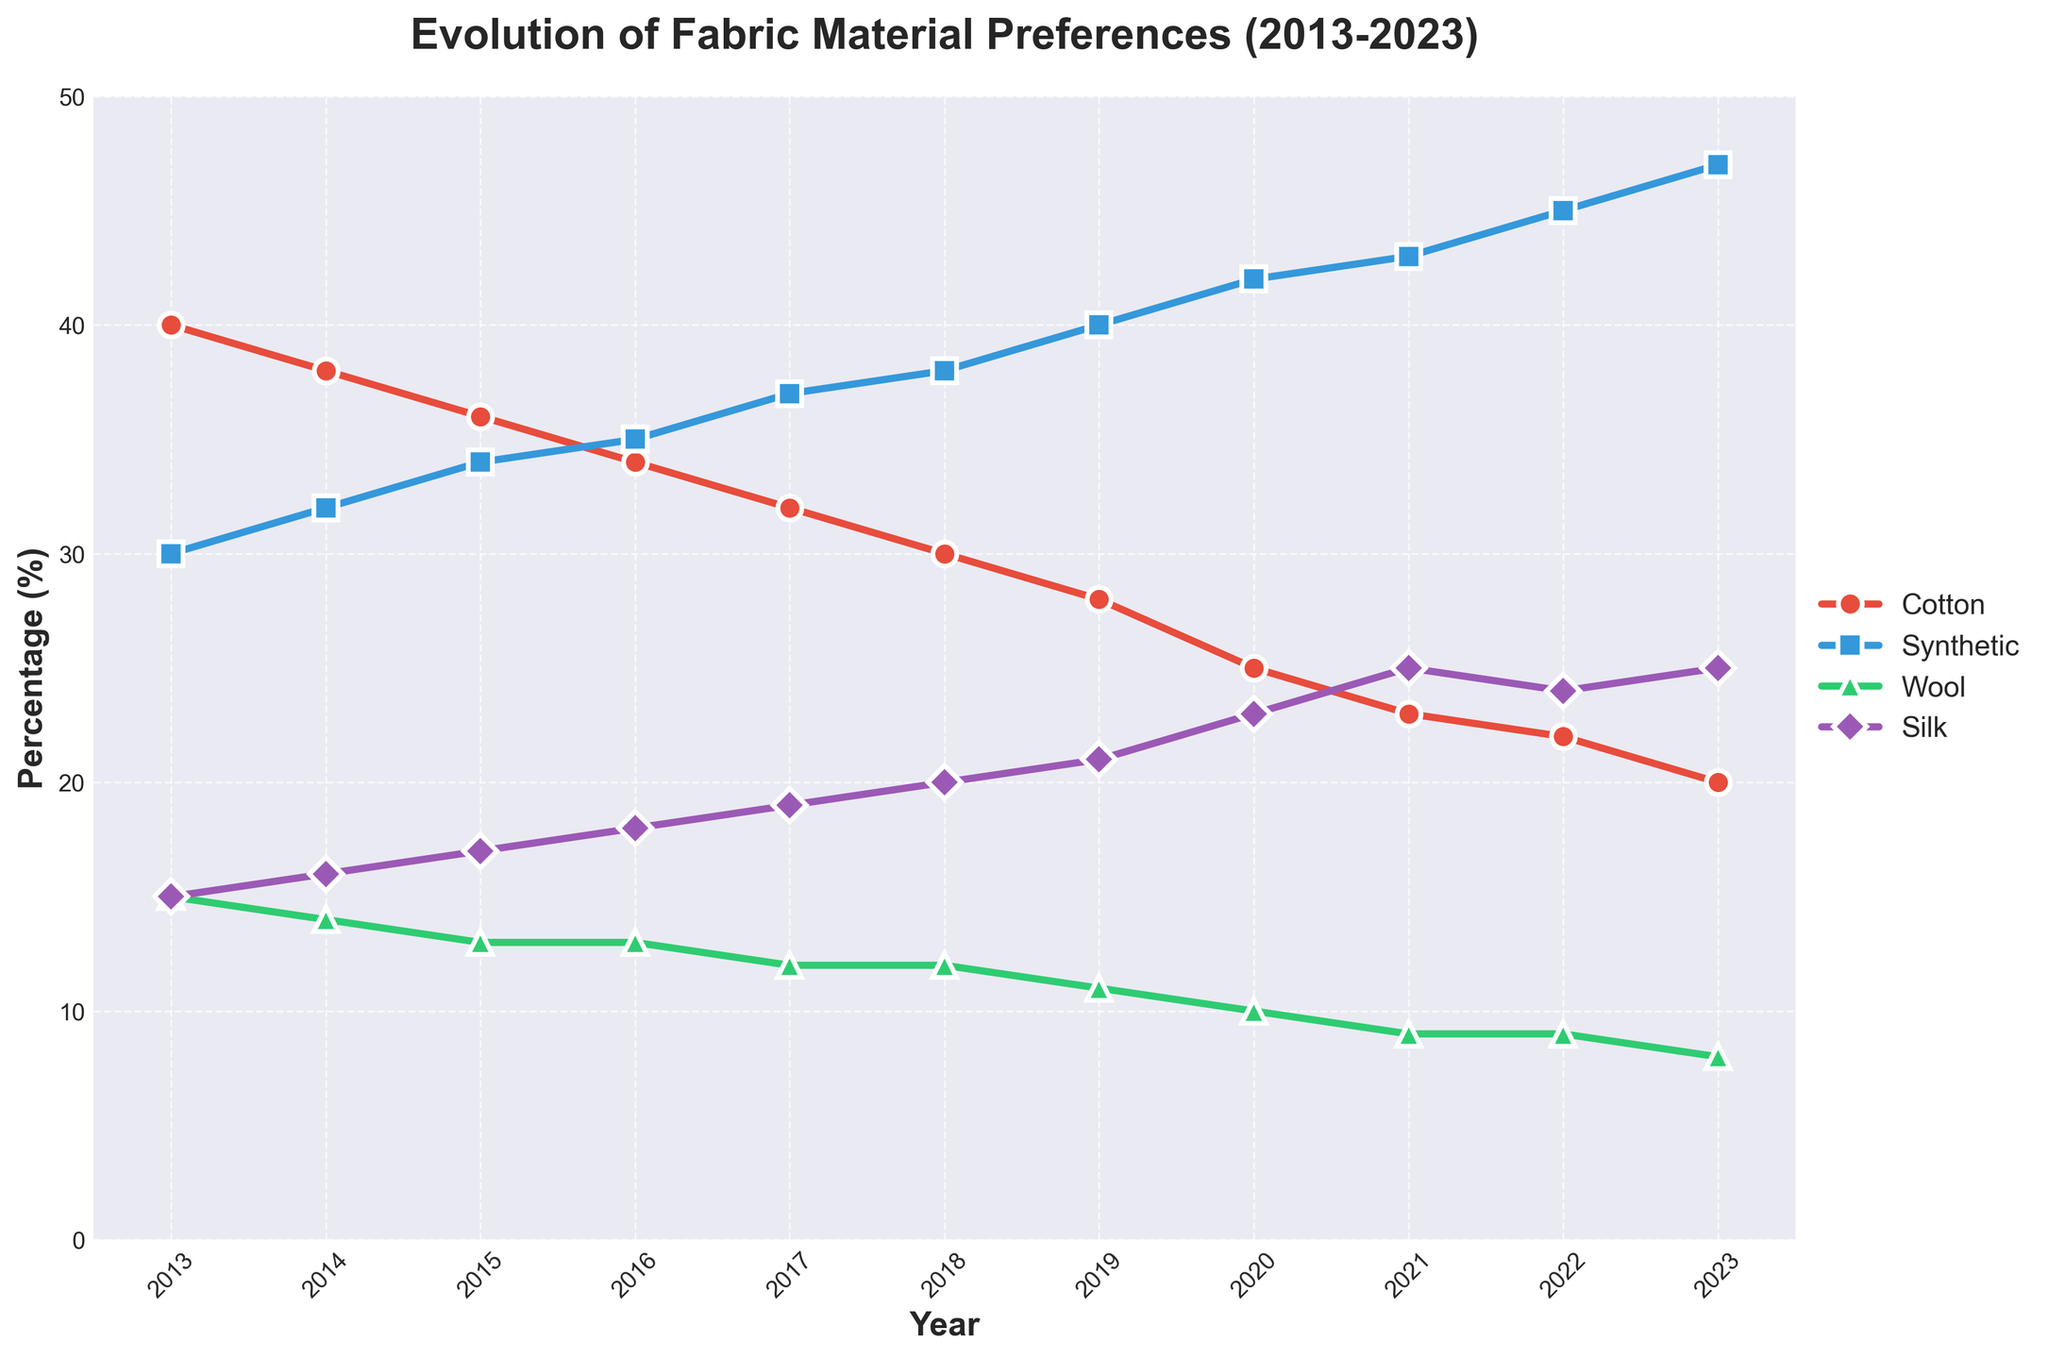What's the title of the figure? The title is located at the top of the figure and clearly states the main focus of the plot.
Answer: Evolution of Fabric Material Preferences (2013-2023) What is the percentage for Cotton in 2023? Find the value for Cotton at the 2023 data point along the Y-axis.
Answer: 20% Compare the percentage of Synthetic and Wool in 2018. Which has a higher percentage? Locate the 2018 data points for both Synthetic and Wool and compare their Y-axis values.
Answer: Synthetic What is the overall trend for Silk from 2013 to 2023? Observe the line representing Silk from 2013 to 2023 to identify if it is increasing, decreasing, or stable.
Answer: Increasing Which year did Synthetic first surpass Cotton in percentage? Identify the year where the line for Synthetic crosses above the line for Cotton.
Answer: 2016 Calculate the difference in percentage between Cotton and Wool in 2015. Subtract the percentage of Wool from the percentage of Cotton for the year 2015.
Answer: 23% What's the average percentage of Silk over the decade? Sum the Silk percentages from 2013 to 2023 and divide by the number of years (11).
Answer: 20% Which material had the least fluctuation in percentage over the decade? Compare the changes in percentage for each material from 2013 to 2023 to identify which one is the most stable.
Answer: Wool In which year did Wool have its lowest percentage, and what was it? Locate the year where the Wool percentage is at its minimum point on the Y-axis.
Answer: 2023, 8% How much did the percentage of Cotton change from 2013 to 2023? Subtract the percentage of Cotton in 2023 from the percentage in 2013.
Answer: -20% 